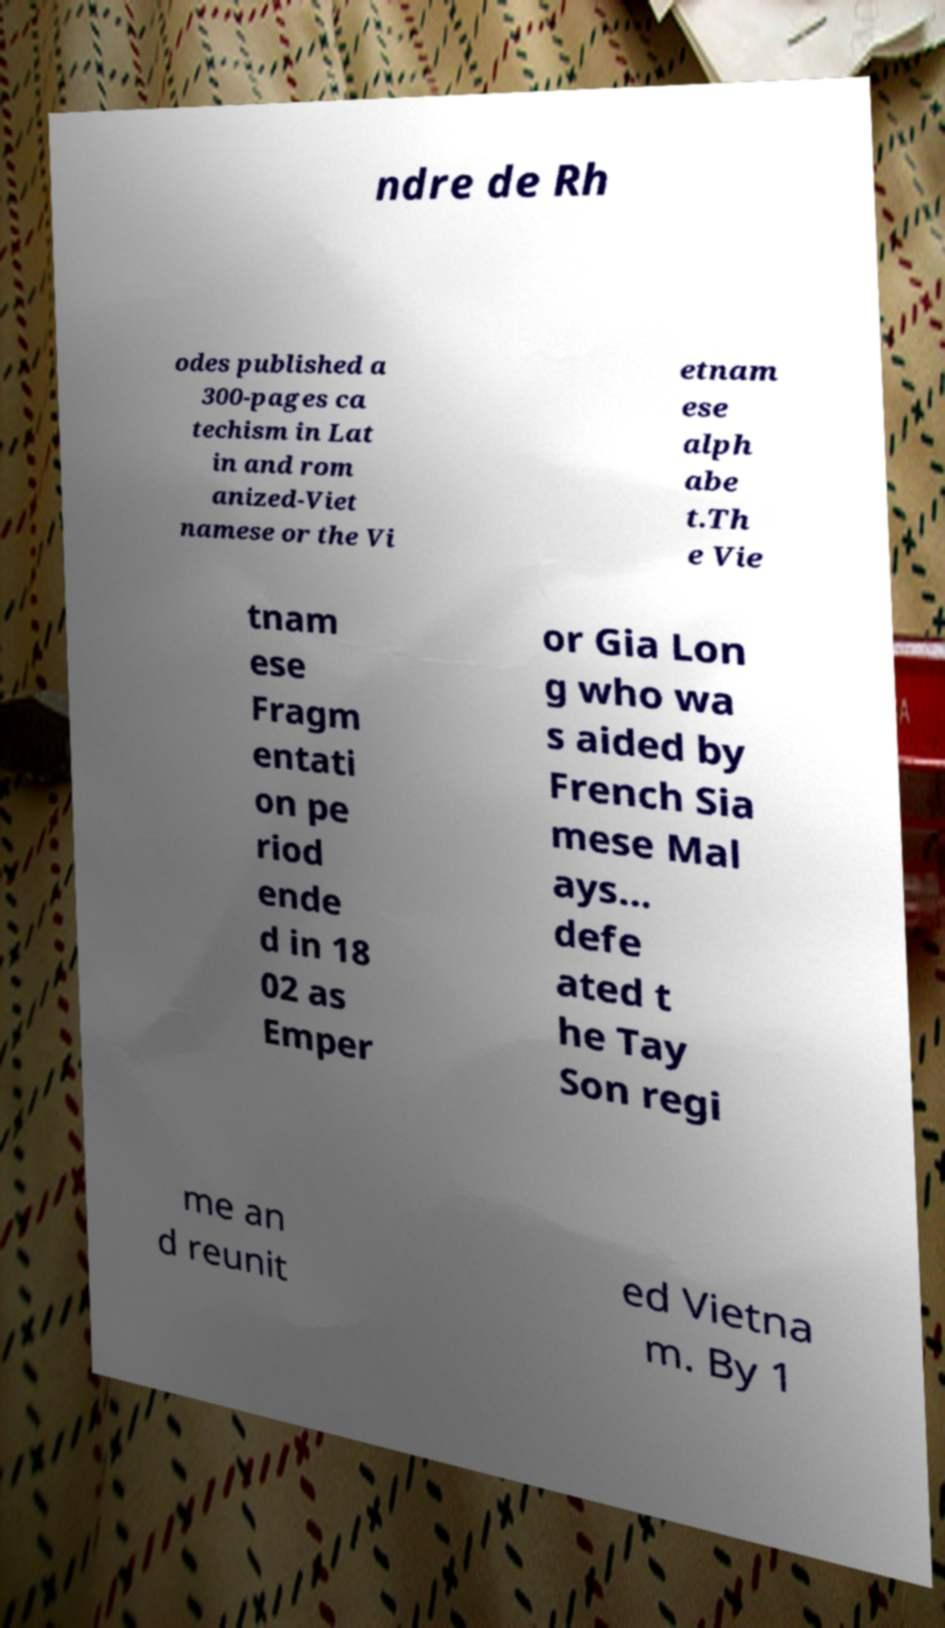Can you accurately transcribe the text from the provided image for me? ndre de Rh odes published a 300-pages ca techism in Lat in and rom anized-Viet namese or the Vi etnam ese alph abe t.Th e Vie tnam ese Fragm entati on pe riod ende d in 18 02 as Emper or Gia Lon g who wa s aided by French Sia mese Mal ays... defe ated t he Tay Son regi me an d reunit ed Vietna m. By 1 